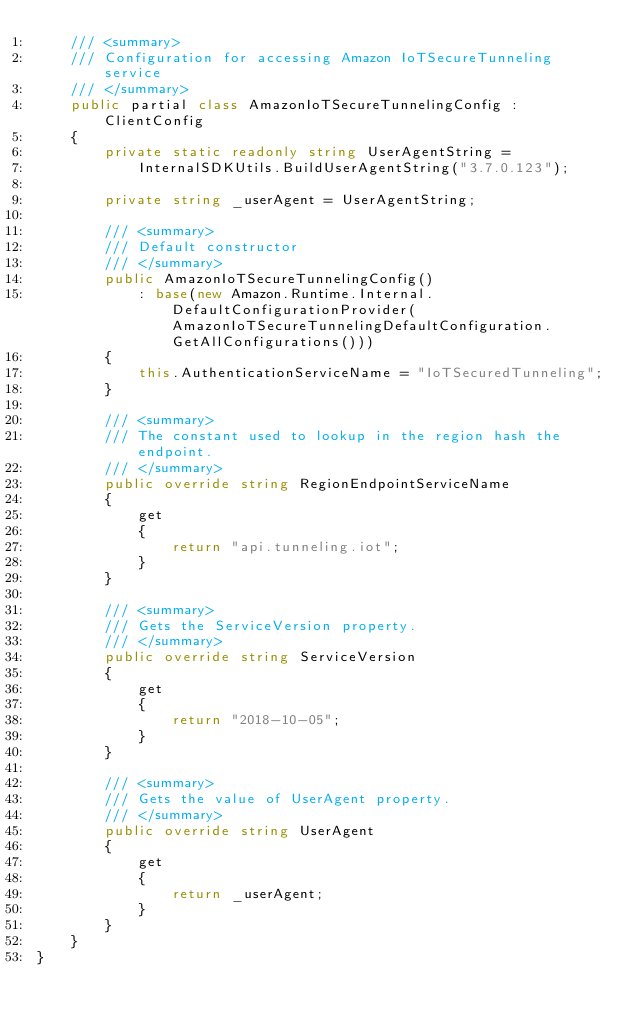<code> <loc_0><loc_0><loc_500><loc_500><_C#_>    /// <summary>
    /// Configuration for accessing Amazon IoTSecureTunneling service
    /// </summary>
    public partial class AmazonIoTSecureTunnelingConfig : ClientConfig
    {
        private static readonly string UserAgentString =
            InternalSDKUtils.BuildUserAgentString("3.7.0.123");

        private string _userAgent = UserAgentString;

        /// <summary>
        /// Default constructor
        /// </summary>
        public AmazonIoTSecureTunnelingConfig()
            : base(new Amazon.Runtime.Internal.DefaultConfigurationProvider(AmazonIoTSecureTunnelingDefaultConfiguration.GetAllConfigurations()))
        {
            this.AuthenticationServiceName = "IoTSecuredTunneling";
        }

        /// <summary>
        /// The constant used to lookup in the region hash the endpoint.
        /// </summary>
        public override string RegionEndpointServiceName
        {
            get
            {
                return "api.tunneling.iot";
            }
        }

        /// <summary>
        /// Gets the ServiceVersion property.
        /// </summary>
        public override string ServiceVersion
        {
            get
            {
                return "2018-10-05";
            }
        }

        /// <summary>
        /// Gets the value of UserAgent property.
        /// </summary>
        public override string UserAgent
        {
            get
            {
                return _userAgent;
            }
        }
    }
}</code> 